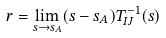Convert formula to latex. <formula><loc_0><loc_0><loc_500><loc_500>r = \lim _ { s \to s _ { A } } ( s - s _ { A } ) T ^ { - 1 } _ { I J } ( s )</formula> 